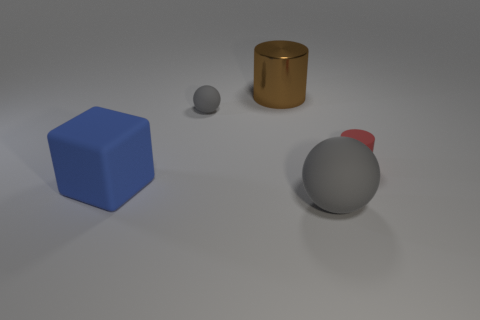Add 5 small purple metal cylinders. How many objects exist? 10 Subtract all cubes. How many objects are left? 4 Add 5 small cylinders. How many small cylinders are left? 6 Add 5 gray things. How many gray things exist? 7 Subtract 2 gray balls. How many objects are left? 3 Subtract all rubber spheres. Subtract all blue metallic cylinders. How many objects are left? 3 